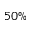Convert formula to latex. <formula><loc_0><loc_0><loc_500><loc_500>5 0 \%</formula> 